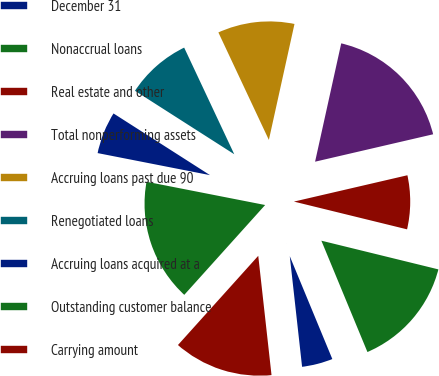<chart> <loc_0><loc_0><loc_500><loc_500><pie_chart><fcel>December 31<fcel>Nonaccrual loans<fcel>Real estate and other<fcel>Total nonperforming assets<fcel>Accruing loans past due 90<fcel>Renegotiated loans<fcel>Accruing loans acquired at a<fcel>Outstanding customer balance<fcel>Carrying amount<nl><fcel>4.48%<fcel>14.93%<fcel>7.46%<fcel>17.91%<fcel>10.45%<fcel>8.96%<fcel>5.97%<fcel>16.42%<fcel>13.43%<nl></chart> 